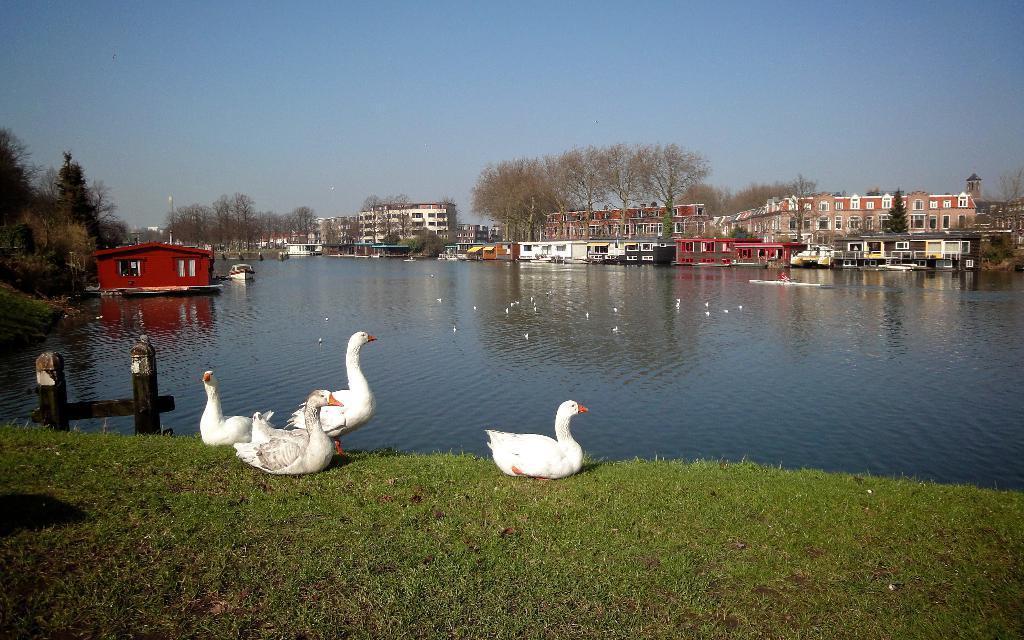Describe this image in one or two sentences. In this image I can see few swans. They are in white and orange color. Back I can see buildings and trees. We can see water. The sky is in blue color. 